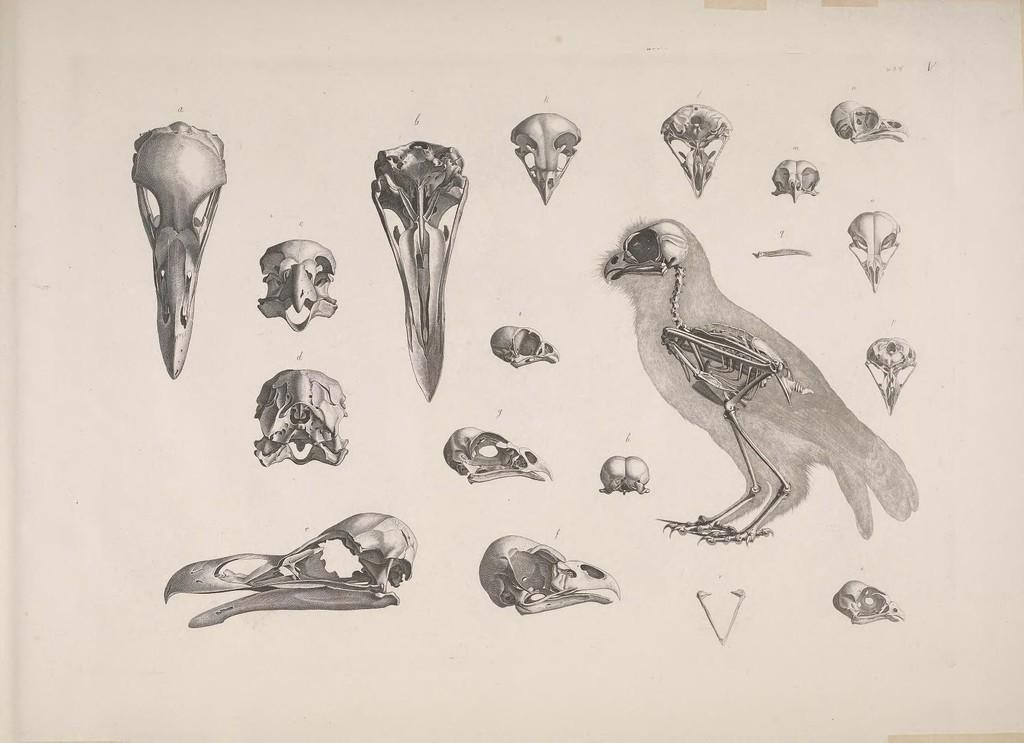What type of animal can be seen in the image? There is a bird in the image. What other objects are present in the image? There are bones and a skull in the image. What color is the background of the image? The background of the image is white. What type of machine can be seen in the image? There is no machine present in the image. How many dimes are visible in the image? There are no dimes present in the image. 